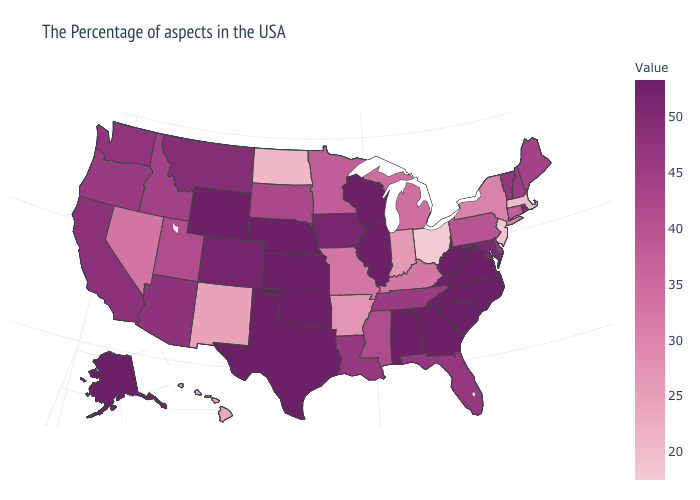Does New Hampshire have a lower value than Hawaii?
Answer briefly. No. Among the states that border Missouri , which have the highest value?
Concise answer only. Illinois, Kansas, Nebraska, Oklahoma. Which states have the lowest value in the USA?
Concise answer only. Ohio. Does the map have missing data?
Concise answer only. No. 